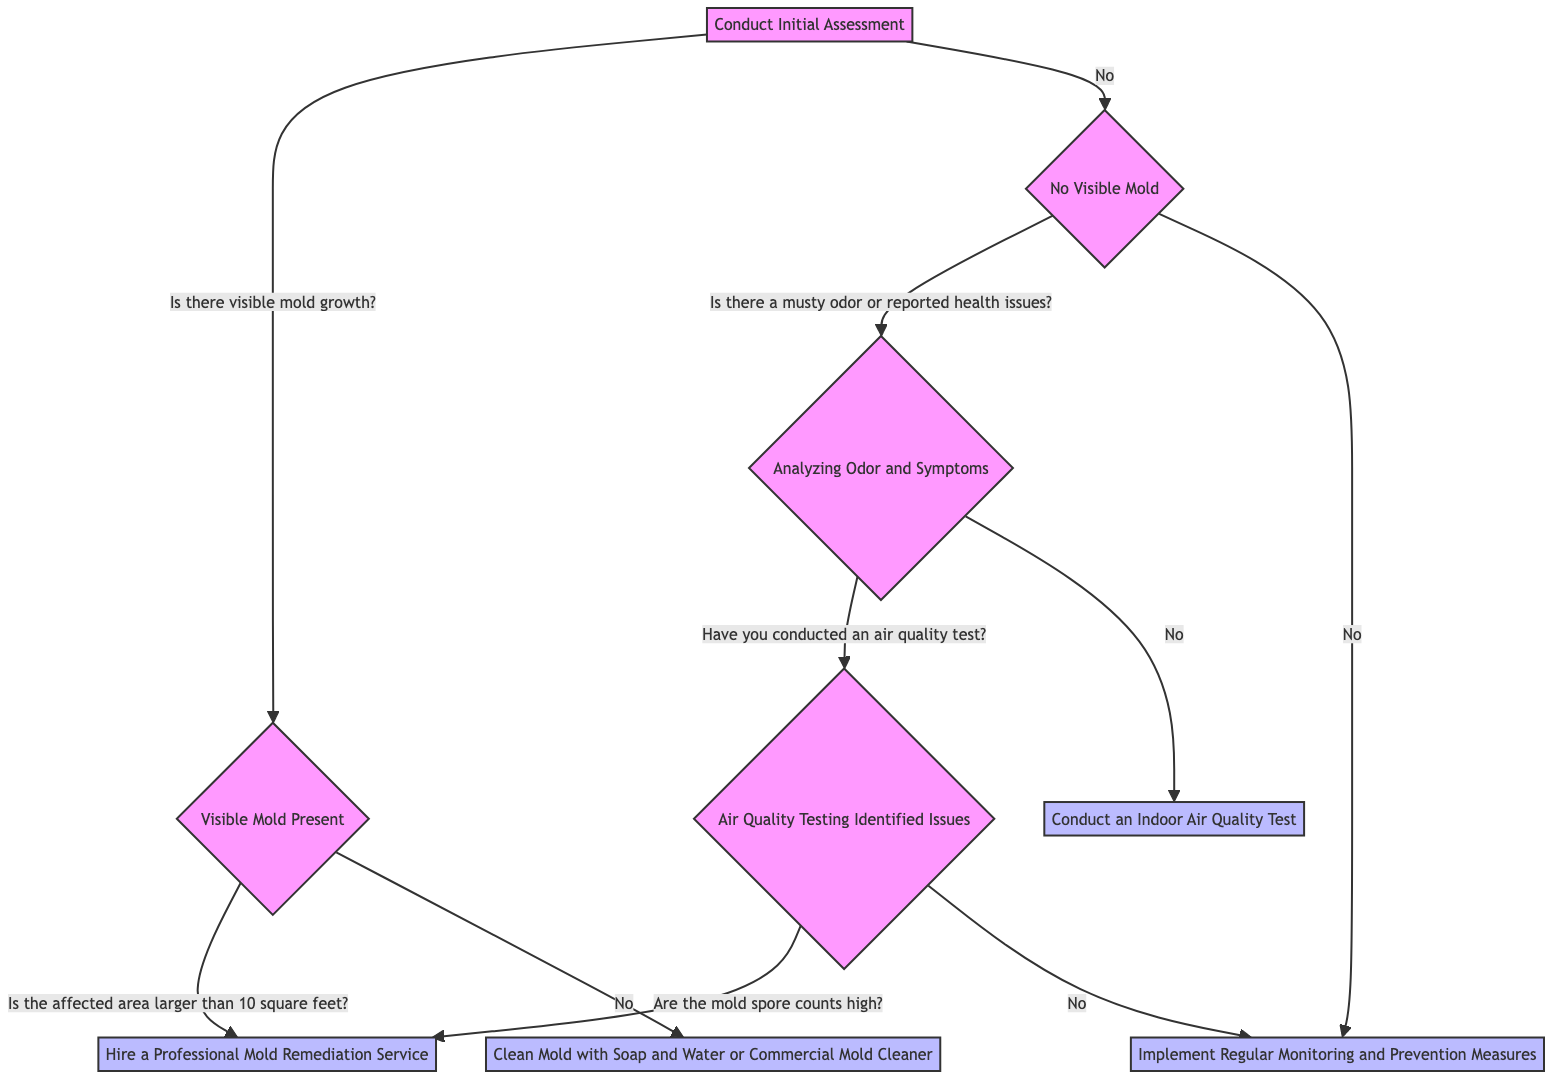What is the first step in the decision tree? The first step in the decision tree is "Conduct Initial Assessment," which is the entry point of the diagram.
Answer: Conduct Initial Assessment How many branches does the "No Visible Mold" node have? The "No Visible Mold" node has two branches: one leading to "Analyzing Odor and Symptoms" (if there is a musty odor or reported health issues) and another leading to "No Mold Indicators" (if there is no musty odor or health issues).
Answer: Two branches What action should be taken if the affected area is larger than 10 square feet? If the affected area is larger than 10 square feet, the diagram indicates the action "Hire a Professional Mold Remediation Service."
Answer: Hire a Professional Mold Remediation Service What should be done if no air quality test has been conducted? If no air quality test has been conducted, the action indicated is "Conduct an Indoor Air Quality Test."
Answer: Conduct an Indoor Air Quality Test What is the action if mold spore counts are low after air quality testing? If the mold spore counts are low after air quality testing, the next step as per the diagram is to implement regular monitoring and prevention measures.
Answer: Implement Regular Monitoring and Prevention Measures If visible mold is present but the area is smaller than 10 square feet, what should be done? If visible mold is present but the area is smaller than 10 square feet, the action to take is "Clean Mold with Soap and Water or Commercial Mold Cleaner."
Answer: Clean Mold with Soap and Water or Commercial Mold Cleaner What must be checked after identifying a musty odor and health issues? After identifying a musty odor and health issues, the diagram indicates to check if an air quality test has been conducted.
Answer: Check for air quality test What happens if mold spore counts are high after air quality testing? If mold spore counts are high after air quality testing, the final action is to "Hire a Professional Mold Remediation Service" as indicated in the decision tree.
Answer: Hire a Professional Mold Remediation Service How many total steps are outlined in the decision tree? The decision tree outlines a total of 9 steps, considering both questions and action items throughout the flow.
Answer: Nine steps 